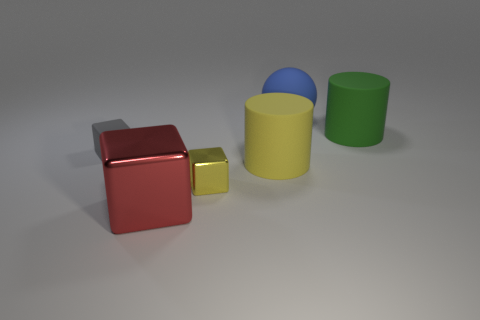Subtract all big cubes. How many cubes are left? 2 Add 2 small gray matte blocks. How many objects exist? 8 Subtract all balls. How many objects are left? 5 Subtract 1 cubes. How many cubes are left? 2 Subtract all gray blocks. How many blocks are left? 2 Add 2 large green things. How many large green things exist? 3 Subtract 0 cyan cylinders. How many objects are left? 6 Subtract all yellow cubes. Subtract all yellow cylinders. How many cubes are left? 2 Subtract all green cylinders. Subtract all big red metal cubes. How many objects are left? 4 Add 6 gray objects. How many gray objects are left? 7 